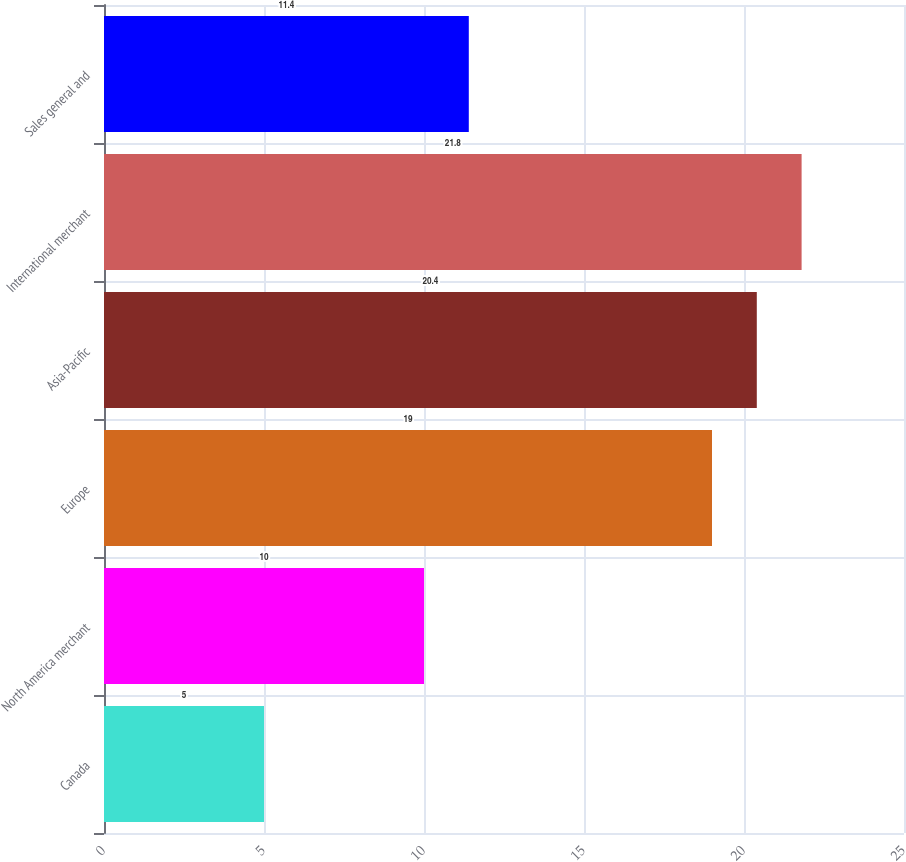<chart> <loc_0><loc_0><loc_500><loc_500><bar_chart><fcel>Canada<fcel>North America merchant<fcel>Europe<fcel>Asia-Pacific<fcel>International merchant<fcel>Sales general and<nl><fcel>5<fcel>10<fcel>19<fcel>20.4<fcel>21.8<fcel>11.4<nl></chart> 